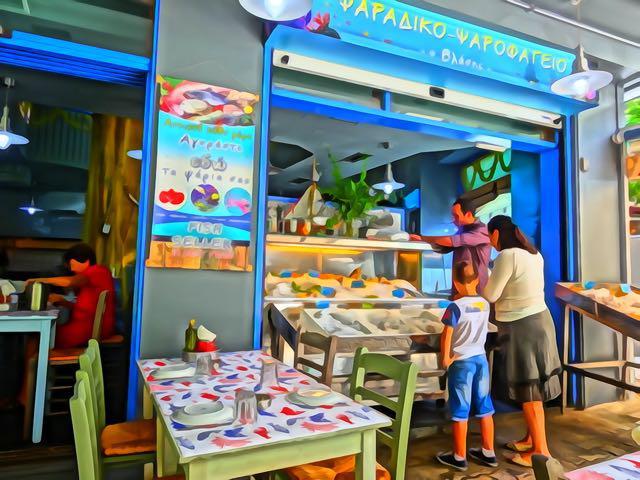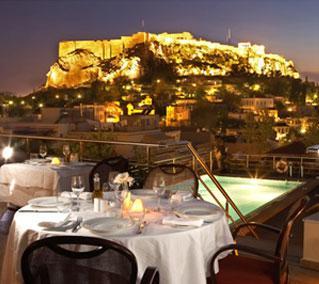The first image is the image on the left, the second image is the image on the right. Analyze the images presented: Is the assertion "All of the tables are covered with cloths." valid? Answer yes or no. Yes. The first image is the image on the left, the second image is the image on the right. For the images displayed, is the sentence "The left image features a man standing and facing-forward in the middle of rectangular tables with rail-backed chairs around them." factually correct? Answer yes or no. No. 